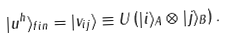Convert formula to latex. <formula><loc_0><loc_0><loc_500><loc_500>| u ^ { h } \rangle _ { f i n } = | v _ { i j } \rangle \equiv U \left ( | i \rangle _ { A } \otimes | j \rangle _ { B } \right ) .</formula> 